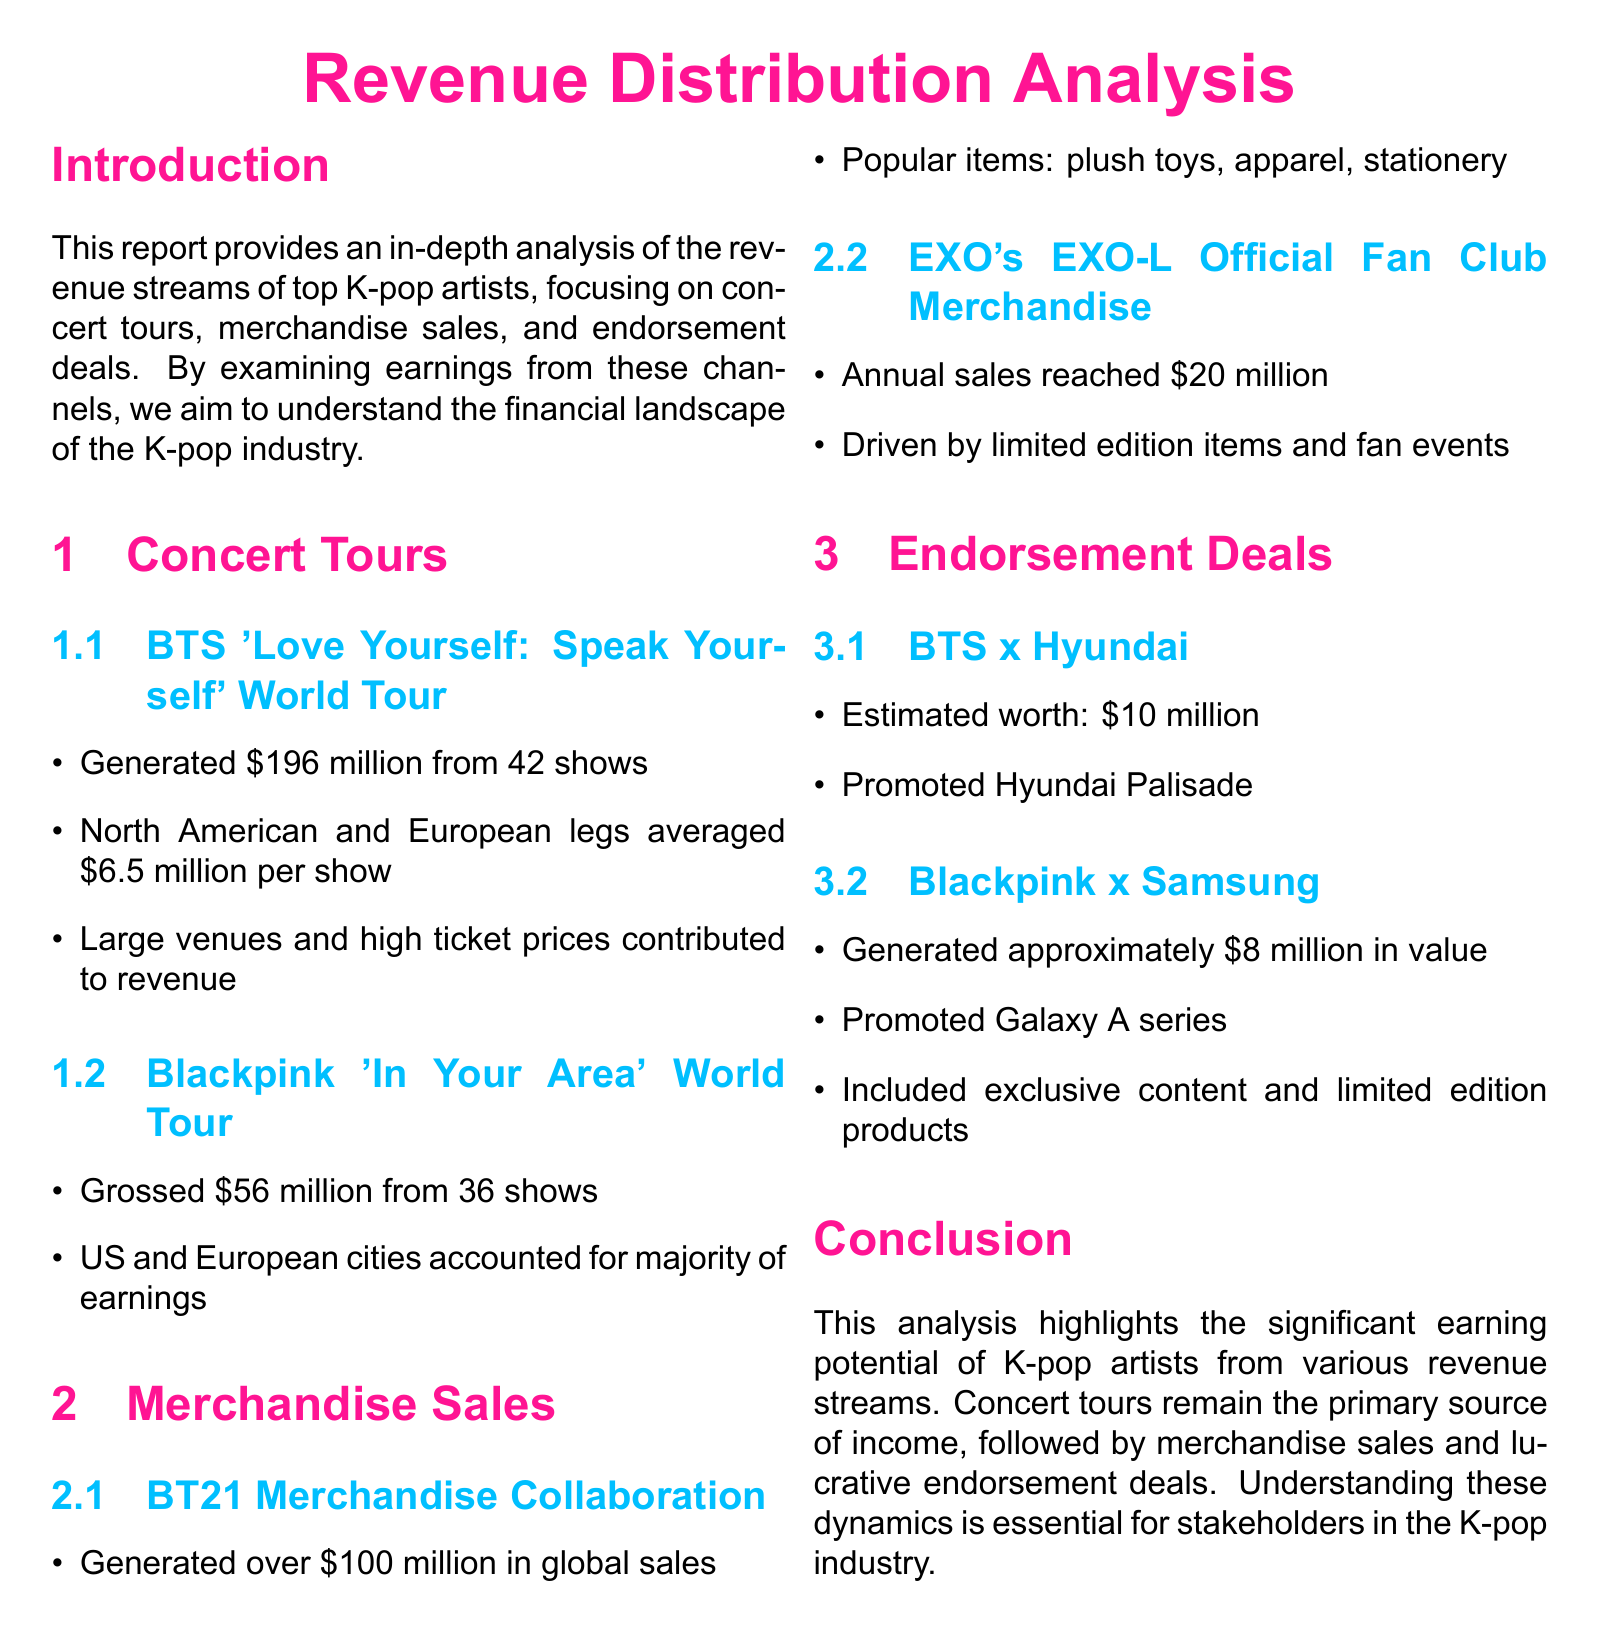What was the gross revenue from BTS's concert tour? The document states that BTS's 'Love Yourself: Speak Yourself' World Tour generated $196 million from 42 shows.
Answer: $196 million What merchandise collaboration generated over $100 million? The report highlights the BT21 Merchandise Collaboration that generated over $100 million in global sales.
Answer: BT21 Merchandise Collaboration What is the estimated worth of BTS's endorsement deal with Hyundai? The document estimates BTS's endorsement deal with Hyundai to be worth $10 million.
Answer: $10 million Which K-pop group grossed $56 million from their world tour? The report indicates that Blackpink's 'In Your Area' World Tour grossed $56 million from 36 shows.
Answer: Blackpink How much did EXO's official fan club merchandise sales reach annually? The document states that EXO's official fan club merchandise annual sales reached $20 million.
Answer: $20 million What were popular items in the BT21 merchandise collaboration? The report mentions plush toys, apparel, and stationery as popular items in the BT21 merchandise collaboration.
Answer: Plush toys, apparel, stationery Which revenue stream is identified as the primary source of income for K-pop artists? The analysis concludes that concert tours are the primary source of income for K-pop artists.
Answer: Concert tours What was the gross revenue for Blackpink's 'In Your Area' World Tour? The document outlines that Blackpink's 'In Your Area' World Tour grossed $56 million.
Answer: $56 million What kind of products were promoted in Blackpink's endorsement deal with Samsung? The document states that Blackpink promoted the Galaxy A series in their endorsement deal with Samsung.
Answer: Galaxy A series 